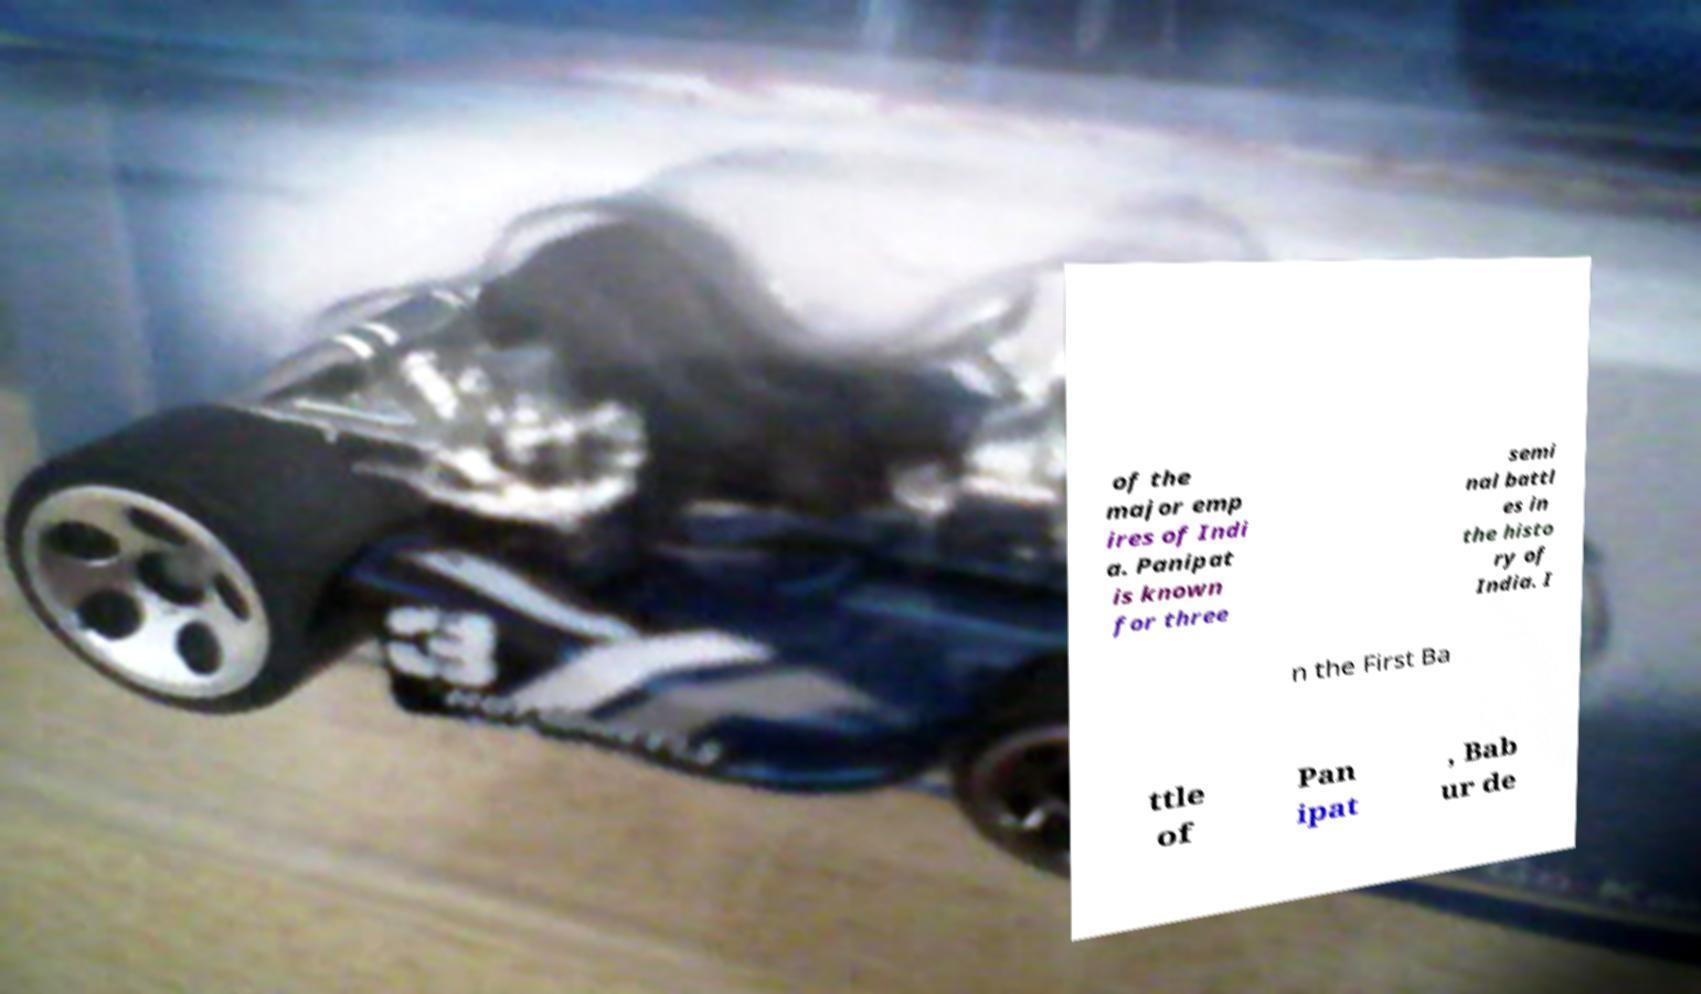Please identify and transcribe the text found in this image. of the major emp ires of Indi a. Panipat is known for three semi nal battl es in the histo ry of India. I n the First Ba ttle of Pan ipat , Bab ur de 